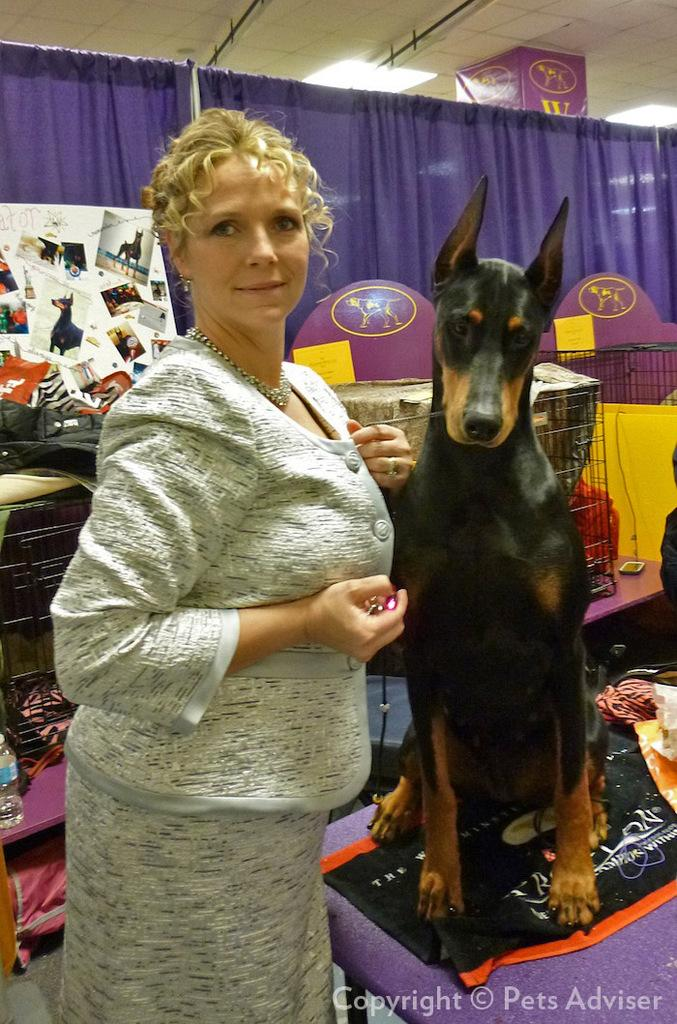What are the people in the image doing? The persons standing at the door suggest they might be about to enter or exit the location. What can be seen in the background of the image? There are grills, a water bottle, a table, photo frames, a curtain, a light, and a ceiling visible in the background. Can you describe the objects on the table in the background? The table in the background has photo frames and a water bottle on it. Can you tell me how many boats are visible in the image? There are no boats present in the image. What type of coat is hanging on the curtain in the image? There is no coat present in the image; only a curtain is visible. 